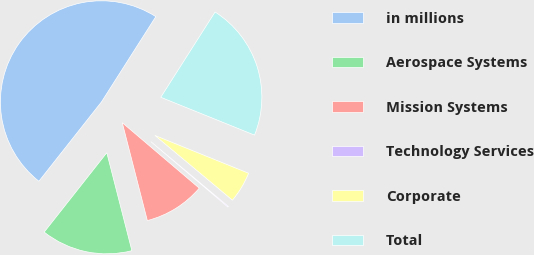<chart> <loc_0><loc_0><loc_500><loc_500><pie_chart><fcel>in millions<fcel>Aerospace Systems<fcel>Mission Systems<fcel>Technology Services<fcel>Corporate<fcel>Total<nl><fcel>48.39%<fcel>14.62%<fcel>9.79%<fcel>0.14%<fcel>4.97%<fcel>22.08%<nl></chart> 